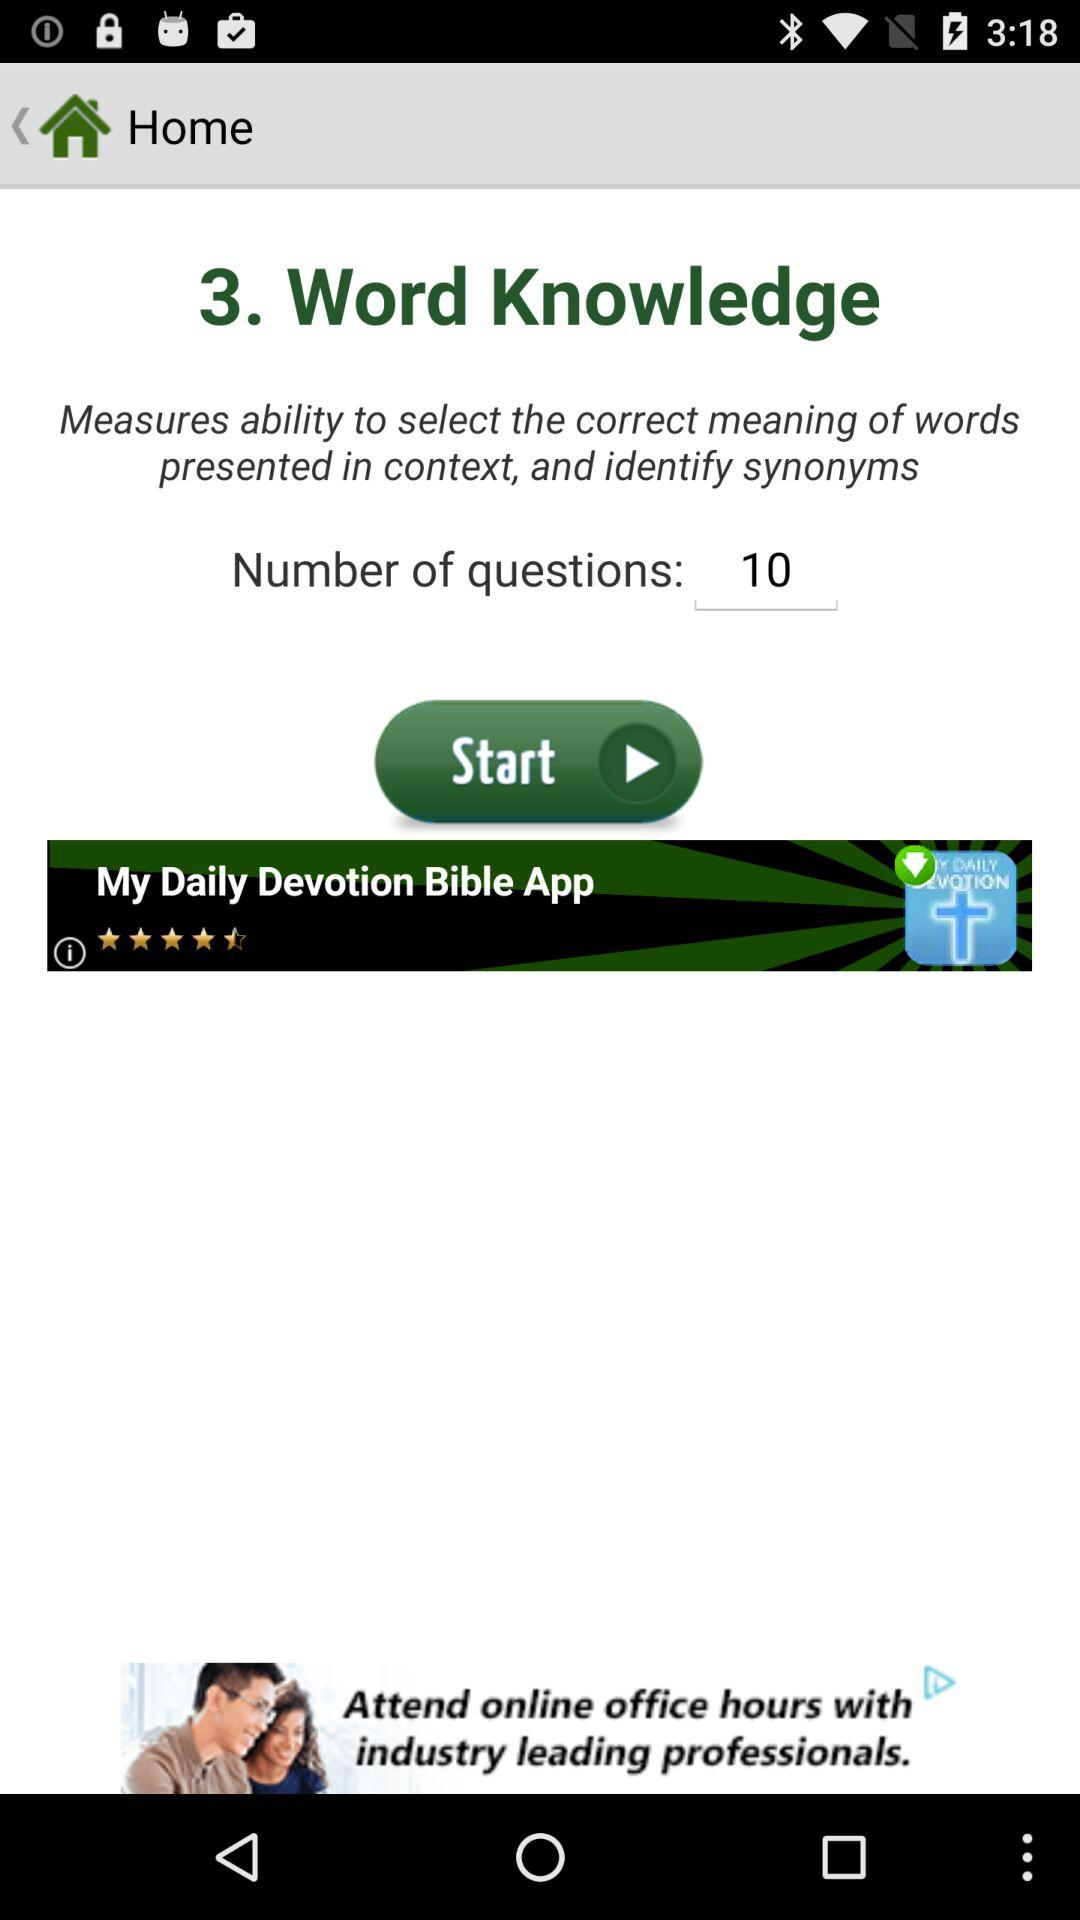How many questions are there on the screen? There are 10 questions on the screen. 